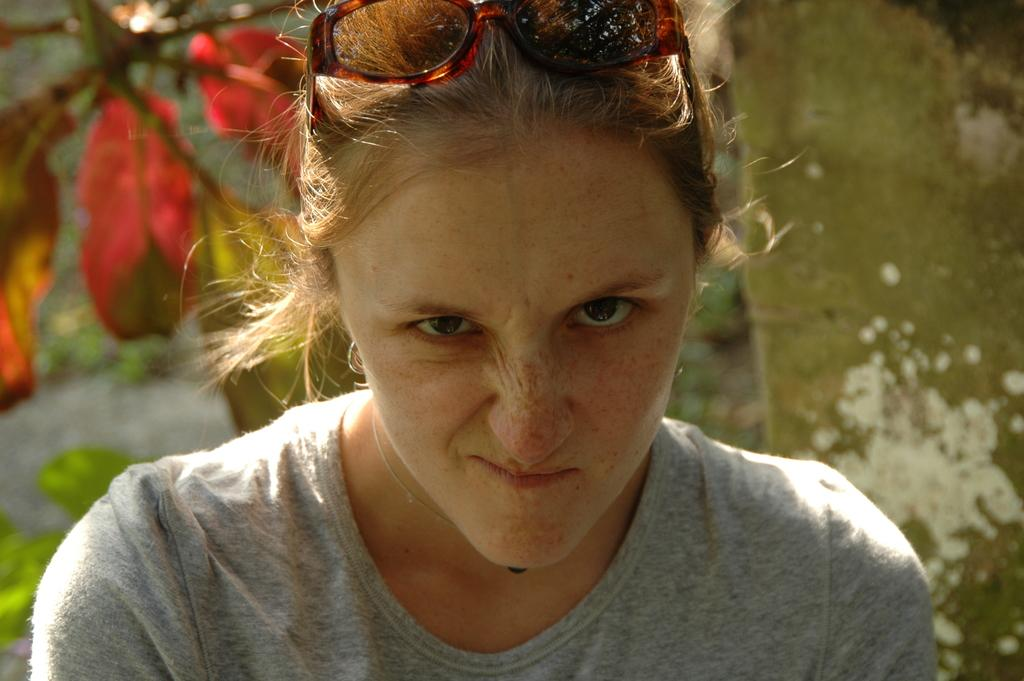What is the woman in the image doing? The woman is sitting in the image. What is the woman wearing on her upper body? The woman is wearing a grey shirt. Does the woman have any accessories in the image? Yes, the woman has glasses. What can be seen on the left side of the image? There are leaves on the left side of the image. How would you describe the background of the image? The backdrop is blurred. What type of sofa is the woman sitting on in the image? There is no sofa present in the image; the woman is sitting on a blurred backdrop. Is the woman wearing a scarf in the image? No, the woman is not wearing a scarf in the image; she is wearing a grey shirt and glasses. 